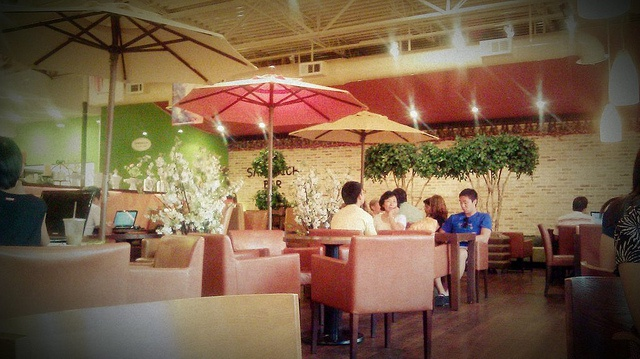Describe the objects in this image and their specific colors. I can see umbrella in black, olive, tan, and maroon tones, chair in black, tan, maroon, and salmon tones, couch in black and gray tones, umbrella in black, salmon, and brown tones, and potted plant in black, darkgreen, and tan tones in this image. 